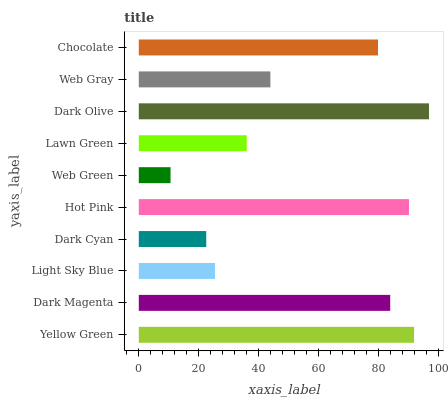Is Web Green the minimum?
Answer yes or no. Yes. Is Dark Olive the maximum?
Answer yes or no. Yes. Is Dark Magenta the minimum?
Answer yes or no. No. Is Dark Magenta the maximum?
Answer yes or no. No. Is Yellow Green greater than Dark Magenta?
Answer yes or no. Yes. Is Dark Magenta less than Yellow Green?
Answer yes or no. Yes. Is Dark Magenta greater than Yellow Green?
Answer yes or no. No. Is Yellow Green less than Dark Magenta?
Answer yes or no. No. Is Chocolate the high median?
Answer yes or no. Yes. Is Web Gray the low median?
Answer yes or no. Yes. Is Hot Pink the high median?
Answer yes or no. No. Is Chocolate the low median?
Answer yes or no. No. 